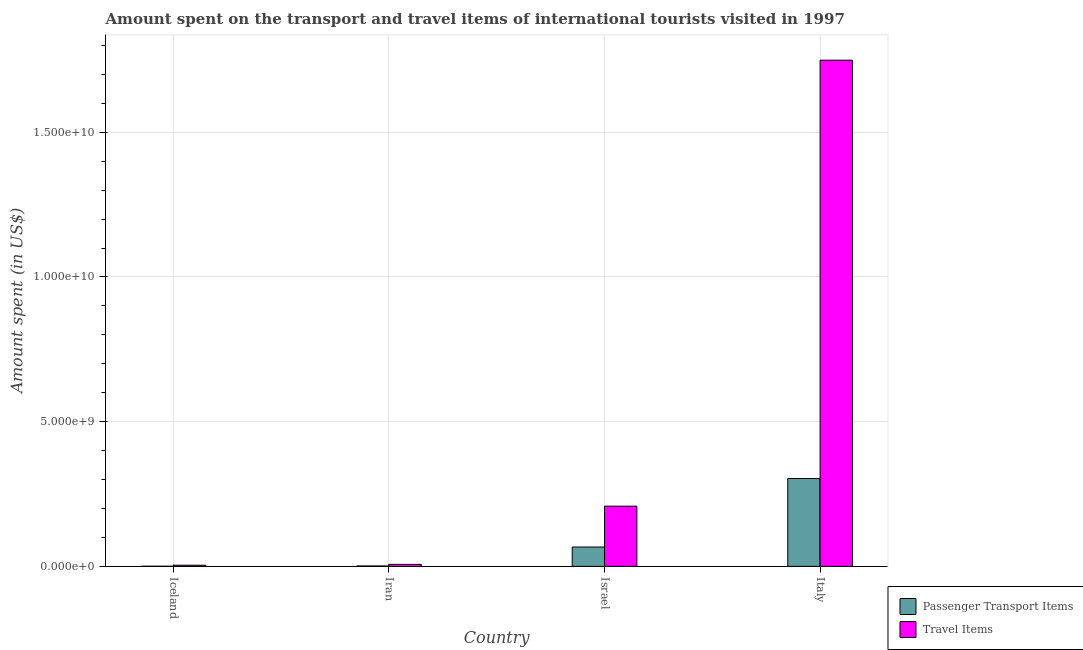Are the number of bars per tick equal to the number of legend labels?
Your answer should be compact. Yes. How many bars are there on the 4th tick from the left?
Keep it short and to the point. 2. How many bars are there on the 1st tick from the right?
Make the answer very short. 2. What is the label of the 3rd group of bars from the left?
Your response must be concise. Israel. In how many cases, is the number of bars for a given country not equal to the number of legend labels?
Provide a short and direct response. 0. What is the amount spent on passenger transport items in Italy?
Provide a succinct answer. 3.04e+09. Across all countries, what is the maximum amount spent in travel items?
Provide a succinct answer. 1.75e+1. Across all countries, what is the minimum amount spent in travel items?
Make the answer very short. 4.00e+07. In which country was the amount spent on passenger transport items maximum?
Provide a short and direct response. Italy. What is the total amount spent on passenger transport items in the graph?
Offer a very short reply. 3.72e+09. What is the difference between the amount spent on passenger transport items in Iceland and that in Italy?
Give a very brief answer. -3.03e+09. What is the difference between the amount spent on passenger transport items in Italy and the amount spent in travel items in Israel?
Offer a terse response. 9.55e+08. What is the average amount spent in travel items per country?
Provide a succinct answer. 4.92e+09. What is the difference between the amount spent in travel items and amount spent on passenger transport items in Italy?
Give a very brief answer. 1.45e+1. What is the ratio of the amount spent on passenger transport items in Iran to that in Israel?
Your answer should be compact. 0.02. Is the amount spent in travel items in Iceland less than that in Italy?
Your answer should be very brief. Yes. What is the difference between the highest and the second highest amount spent on passenger transport items?
Keep it short and to the point. 2.37e+09. What is the difference between the highest and the lowest amount spent in travel items?
Offer a very short reply. 1.74e+1. Is the sum of the amount spent on passenger transport items in Iceland and Italy greater than the maximum amount spent in travel items across all countries?
Offer a very short reply. No. What does the 2nd bar from the left in Iran represents?
Offer a very short reply. Travel Items. What does the 2nd bar from the right in Israel represents?
Offer a terse response. Passenger Transport Items. Are the values on the major ticks of Y-axis written in scientific E-notation?
Your response must be concise. Yes. Does the graph contain any zero values?
Your response must be concise. No. Does the graph contain grids?
Ensure brevity in your answer.  Yes. Where does the legend appear in the graph?
Keep it short and to the point. Bottom right. How are the legend labels stacked?
Keep it short and to the point. Vertical. What is the title of the graph?
Your answer should be very brief. Amount spent on the transport and travel items of international tourists visited in 1997. Does "Export" appear as one of the legend labels in the graph?
Offer a very short reply. No. What is the label or title of the X-axis?
Offer a very short reply. Country. What is the label or title of the Y-axis?
Your answer should be very brief. Amount spent (in US$). What is the Amount spent (in US$) of Passenger Transport Items in Iceland?
Give a very brief answer. 4.00e+06. What is the Amount spent (in US$) in Travel Items in Iceland?
Provide a short and direct response. 4.00e+07. What is the Amount spent (in US$) of Passenger Transport Items in Iran?
Offer a terse response. 1.40e+07. What is the Amount spent (in US$) in Travel Items in Iran?
Provide a short and direct response. 6.90e+07. What is the Amount spent (in US$) in Passenger Transport Items in Israel?
Your answer should be compact. 6.69e+08. What is the Amount spent (in US$) in Travel Items in Israel?
Your response must be concise. 2.08e+09. What is the Amount spent (in US$) in Passenger Transport Items in Italy?
Offer a terse response. 3.04e+09. What is the Amount spent (in US$) of Travel Items in Italy?
Ensure brevity in your answer.  1.75e+1. Across all countries, what is the maximum Amount spent (in US$) of Passenger Transport Items?
Give a very brief answer. 3.04e+09. Across all countries, what is the maximum Amount spent (in US$) of Travel Items?
Provide a short and direct response. 1.75e+1. Across all countries, what is the minimum Amount spent (in US$) in Passenger Transport Items?
Offer a terse response. 4.00e+06. Across all countries, what is the minimum Amount spent (in US$) of Travel Items?
Keep it short and to the point. 4.00e+07. What is the total Amount spent (in US$) in Passenger Transport Items in the graph?
Give a very brief answer. 3.72e+09. What is the total Amount spent (in US$) in Travel Items in the graph?
Offer a very short reply. 1.97e+1. What is the difference between the Amount spent (in US$) of Passenger Transport Items in Iceland and that in Iran?
Make the answer very short. -1.00e+07. What is the difference between the Amount spent (in US$) in Travel Items in Iceland and that in Iran?
Your answer should be compact. -2.90e+07. What is the difference between the Amount spent (in US$) in Passenger Transport Items in Iceland and that in Israel?
Your response must be concise. -6.65e+08. What is the difference between the Amount spent (in US$) of Travel Items in Iceland and that in Israel?
Make the answer very short. -2.04e+09. What is the difference between the Amount spent (in US$) of Passenger Transport Items in Iceland and that in Italy?
Your answer should be very brief. -3.03e+09. What is the difference between the Amount spent (in US$) of Travel Items in Iceland and that in Italy?
Provide a succinct answer. -1.74e+1. What is the difference between the Amount spent (in US$) in Passenger Transport Items in Iran and that in Israel?
Keep it short and to the point. -6.55e+08. What is the difference between the Amount spent (in US$) in Travel Items in Iran and that in Israel?
Provide a succinct answer. -2.01e+09. What is the difference between the Amount spent (in US$) in Passenger Transport Items in Iran and that in Italy?
Your answer should be very brief. -3.02e+09. What is the difference between the Amount spent (in US$) in Travel Items in Iran and that in Italy?
Make the answer very short. -1.74e+1. What is the difference between the Amount spent (in US$) in Passenger Transport Items in Israel and that in Italy?
Provide a short and direct response. -2.37e+09. What is the difference between the Amount spent (in US$) in Travel Items in Israel and that in Italy?
Offer a very short reply. -1.54e+1. What is the difference between the Amount spent (in US$) of Passenger Transport Items in Iceland and the Amount spent (in US$) of Travel Items in Iran?
Make the answer very short. -6.50e+07. What is the difference between the Amount spent (in US$) of Passenger Transport Items in Iceland and the Amount spent (in US$) of Travel Items in Israel?
Make the answer very short. -2.08e+09. What is the difference between the Amount spent (in US$) of Passenger Transport Items in Iceland and the Amount spent (in US$) of Travel Items in Italy?
Your answer should be compact. -1.75e+1. What is the difference between the Amount spent (in US$) in Passenger Transport Items in Iran and the Amount spent (in US$) in Travel Items in Israel?
Keep it short and to the point. -2.07e+09. What is the difference between the Amount spent (in US$) in Passenger Transport Items in Iran and the Amount spent (in US$) in Travel Items in Italy?
Make the answer very short. -1.75e+1. What is the difference between the Amount spent (in US$) of Passenger Transport Items in Israel and the Amount spent (in US$) of Travel Items in Italy?
Give a very brief answer. -1.68e+1. What is the average Amount spent (in US$) in Passenger Transport Items per country?
Give a very brief answer. 9.30e+08. What is the average Amount spent (in US$) of Travel Items per country?
Keep it short and to the point. 4.92e+09. What is the difference between the Amount spent (in US$) in Passenger Transport Items and Amount spent (in US$) in Travel Items in Iceland?
Make the answer very short. -3.60e+07. What is the difference between the Amount spent (in US$) in Passenger Transport Items and Amount spent (in US$) in Travel Items in Iran?
Give a very brief answer. -5.50e+07. What is the difference between the Amount spent (in US$) of Passenger Transport Items and Amount spent (in US$) of Travel Items in Israel?
Provide a short and direct response. -1.41e+09. What is the difference between the Amount spent (in US$) in Passenger Transport Items and Amount spent (in US$) in Travel Items in Italy?
Your response must be concise. -1.45e+1. What is the ratio of the Amount spent (in US$) in Passenger Transport Items in Iceland to that in Iran?
Your response must be concise. 0.29. What is the ratio of the Amount spent (in US$) of Travel Items in Iceland to that in Iran?
Offer a terse response. 0.58. What is the ratio of the Amount spent (in US$) in Passenger Transport Items in Iceland to that in Israel?
Make the answer very short. 0.01. What is the ratio of the Amount spent (in US$) of Travel Items in Iceland to that in Israel?
Give a very brief answer. 0.02. What is the ratio of the Amount spent (in US$) of Passenger Transport Items in Iceland to that in Italy?
Provide a short and direct response. 0. What is the ratio of the Amount spent (in US$) in Travel Items in Iceland to that in Italy?
Provide a succinct answer. 0. What is the ratio of the Amount spent (in US$) in Passenger Transport Items in Iran to that in Israel?
Offer a very short reply. 0.02. What is the ratio of the Amount spent (in US$) in Travel Items in Iran to that in Israel?
Keep it short and to the point. 0.03. What is the ratio of the Amount spent (in US$) of Passenger Transport Items in Iran to that in Italy?
Give a very brief answer. 0. What is the ratio of the Amount spent (in US$) in Travel Items in Iran to that in Italy?
Your response must be concise. 0. What is the ratio of the Amount spent (in US$) of Passenger Transport Items in Israel to that in Italy?
Your answer should be very brief. 0.22. What is the ratio of the Amount spent (in US$) of Travel Items in Israel to that in Italy?
Give a very brief answer. 0.12. What is the difference between the highest and the second highest Amount spent (in US$) in Passenger Transport Items?
Give a very brief answer. 2.37e+09. What is the difference between the highest and the second highest Amount spent (in US$) in Travel Items?
Your answer should be very brief. 1.54e+1. What is the difference between the highest and the lowest Amount spent (in US$) in Passenger Transport Items?
Your answer should be compact. 3.03e+09. What is the difference between the highest and the lowest Amount spent (in US$) of Travel Items?
Ensure brevity in your answer.  1.74e+1. 